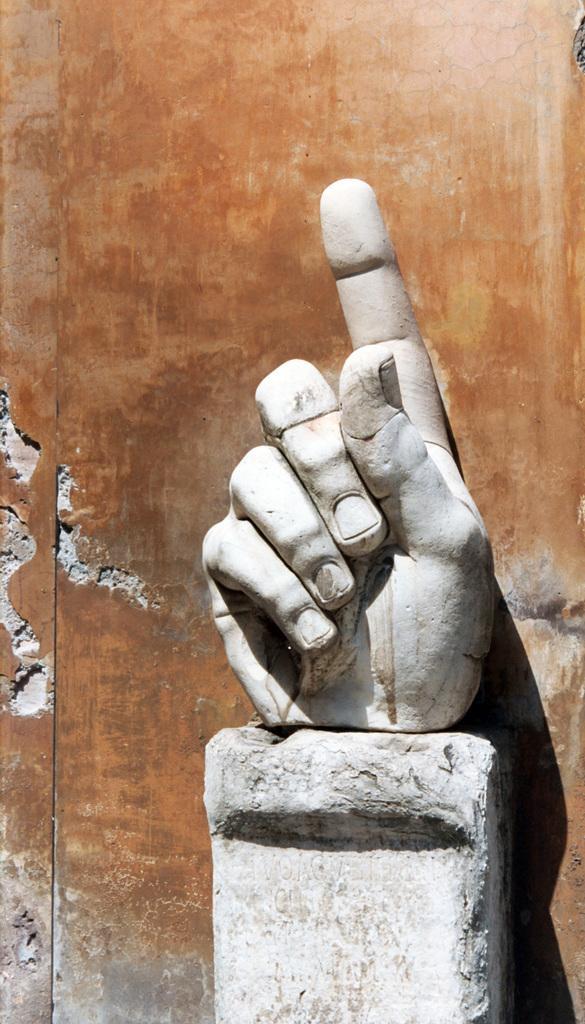Describe this image in one or two sentences. In the picture I can see a sculpture of a hand. In the background I can see a wall. The sculpture is white in color. 